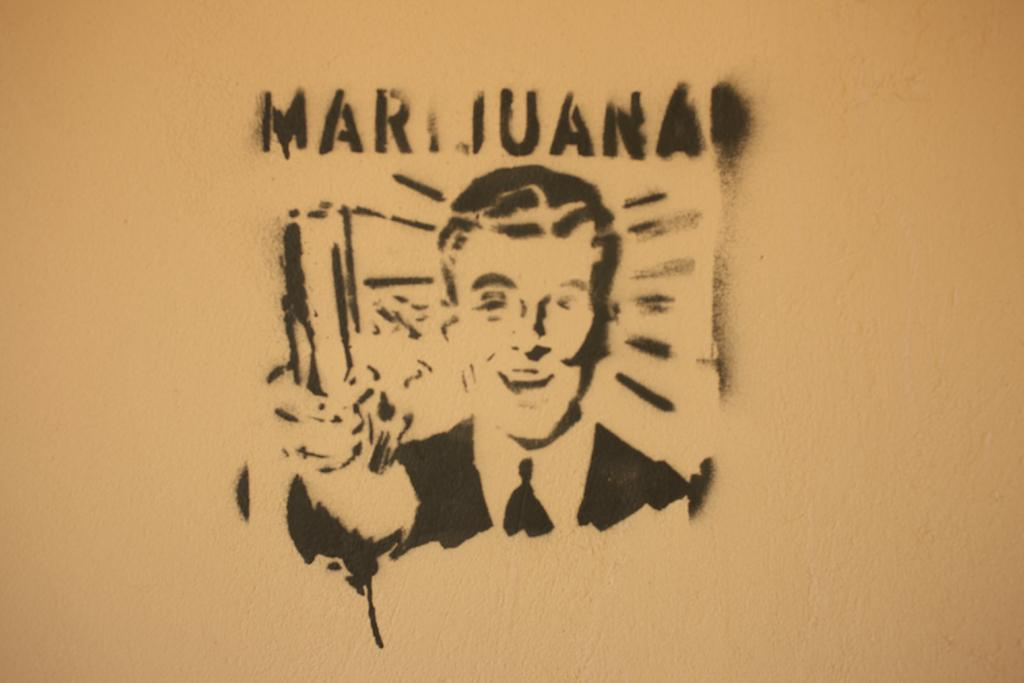What is depicted on the wall in the image? There is a design of a person on the wall. Can you read the name of the person in the design? Yes, the name of the person is visible at the top of the design. What type of fish is being sold at the produce stand in the image? There is no produce stand or fish present in the image; it features a design of a person on the wall with their name visible. 